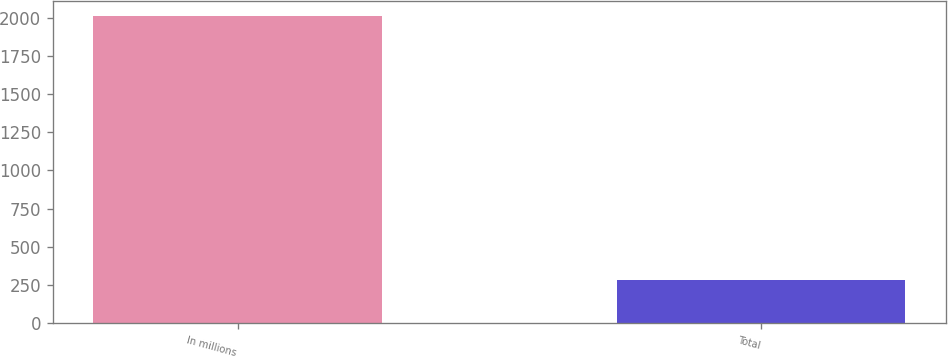Convert chart to OTSL. <chart><loc_0><loc_0><loc_500><loc_500><bar_chart><fcel>In millions<fcel>Total<nl><fcel>2010<fcel>283<nl></chart> 